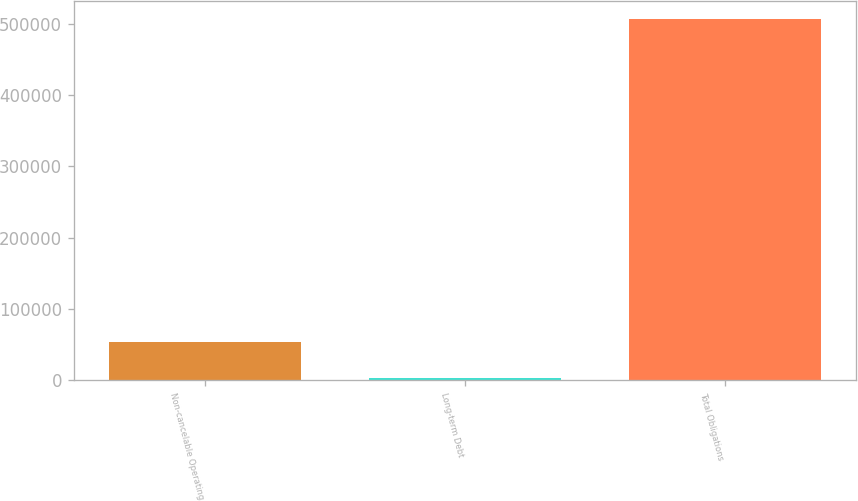<chart> <loc_0><loc_0><loc_500><loc_500><bar_chart><fcel>Non-cancelable Operating<fcel>Long-term Debt<fcel>Total Obligations<nl><fcel>53348.8<fcel>2990<fcel>506578<nl></chart> 